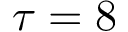Convert formula to latex. <formula><loc_0><loc_0><loc_500><loc_500>\tau = 8</formula> 